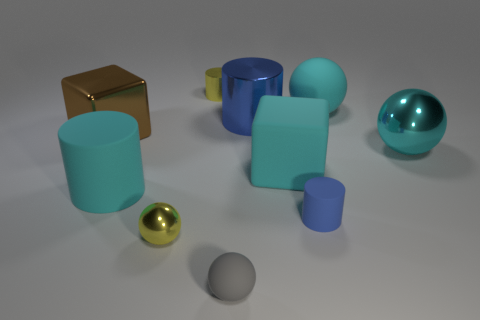How many things are large cyan things or cyan objects to the right of the cyan matte sphere? There are three large cyan objects in the image: two matte cylinders and one cube. However, to the right of the cyan matte sphere, there is only one cyan object, which is a matte cylinder. 